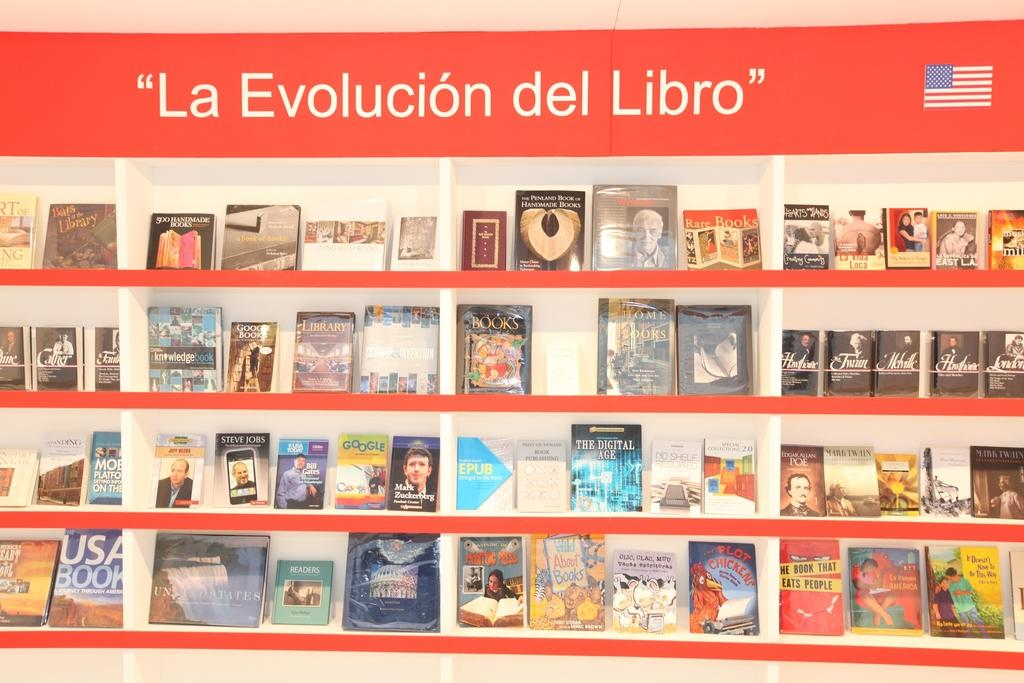<image>
Summarize the visual content of the image. A display of books is captioned "la evolucion del libro." 